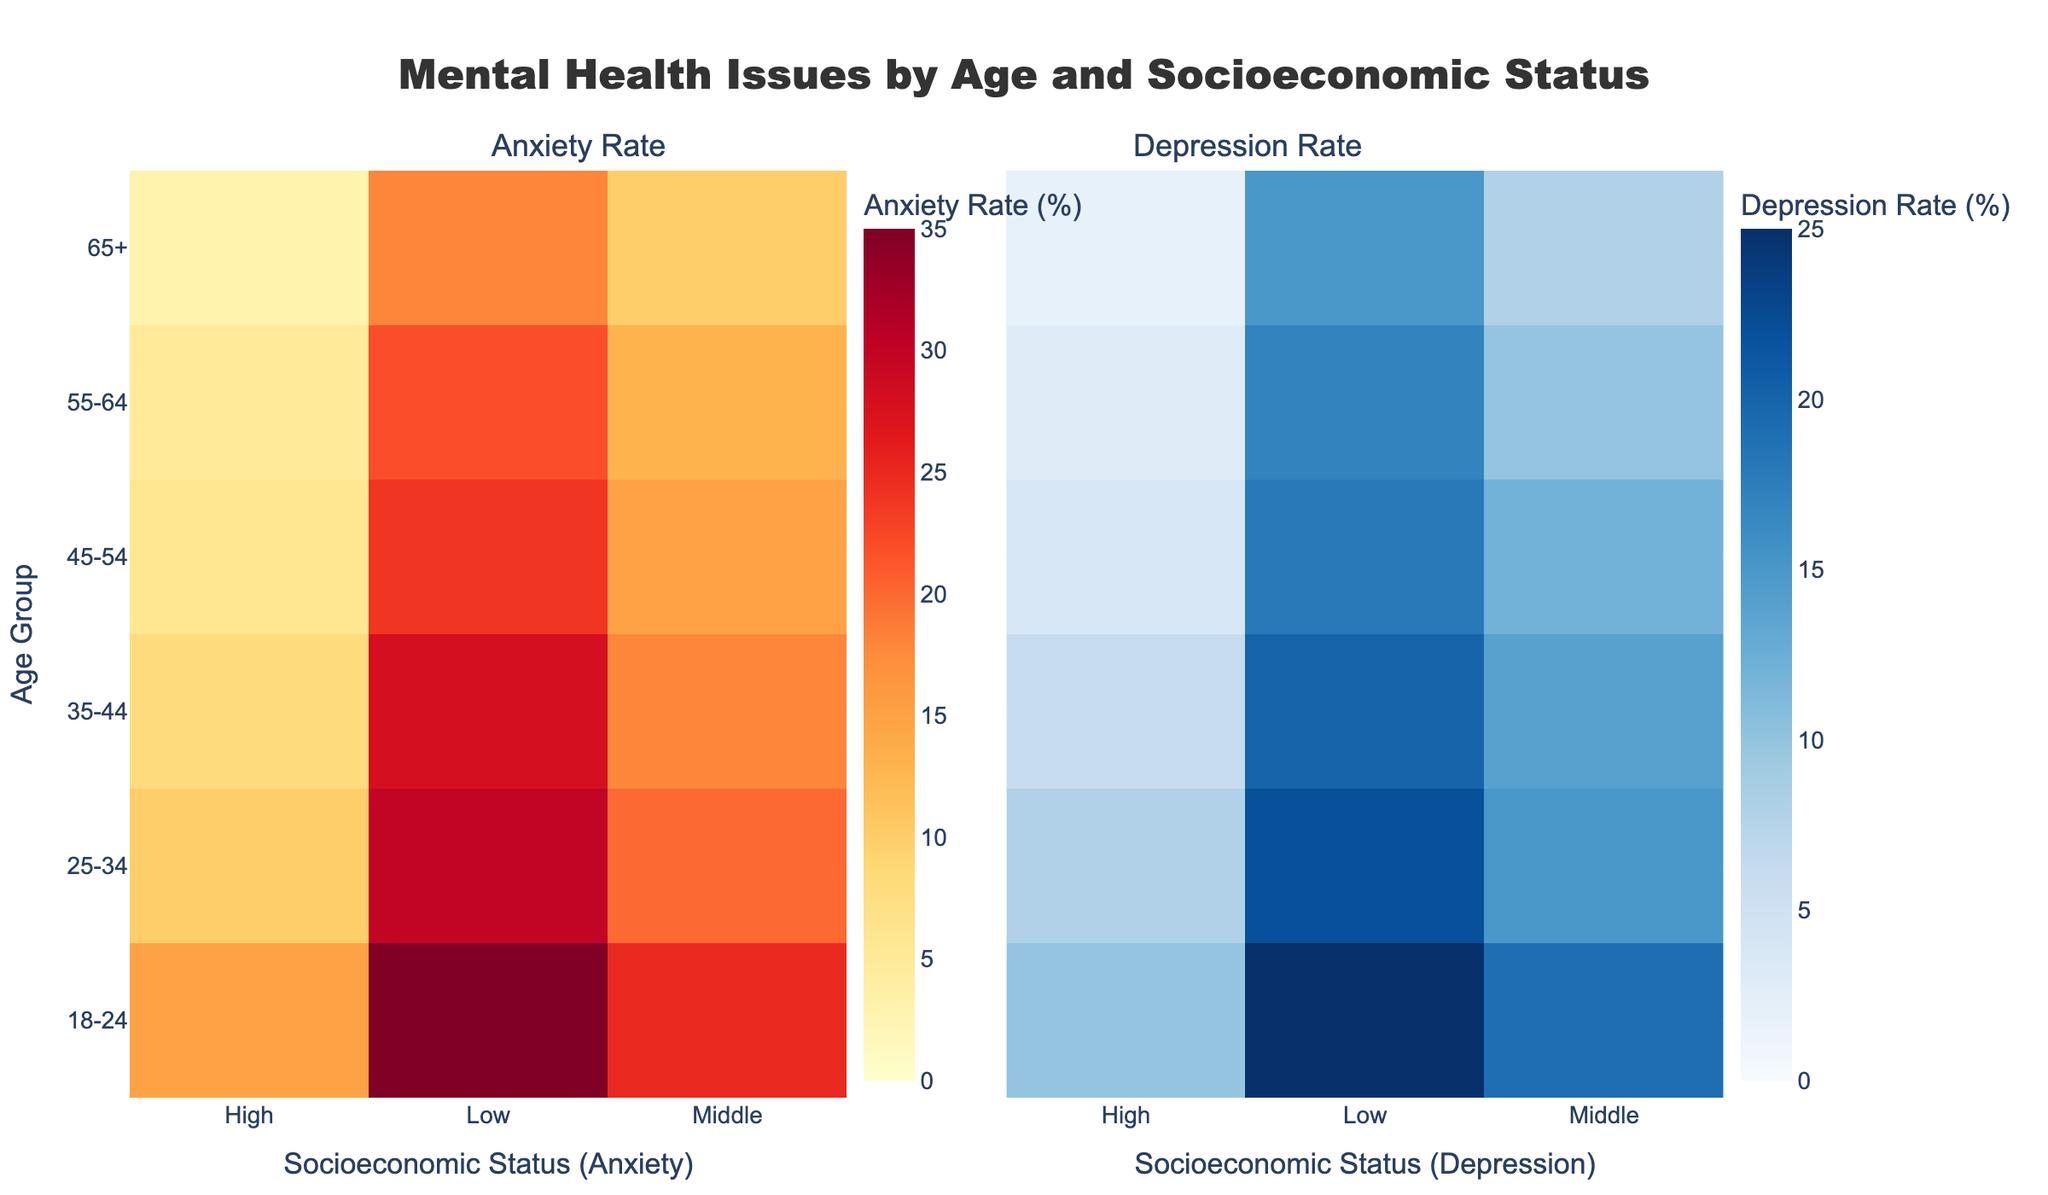What is the title of the figure? The title of the figure is usually displayed at the top. Based on the provided code, the title is located by identifying the 'title' parameter in the layout update section.
Answer: Mental Health Issues by Age and Socioeconomic Status What is the socioeconomic status with the highest anxiety rate for 18-24 age group? You can find this by looking at the heatmap cells corresponding to the 18-24 age group along the Anxiety Rate axis. The color intensity scale indicates the rate, where the highest intensity corresponds to the highest rate.
Answer: Low How does the anxiety rate change from the 18-24 to the 65+ age group for those in the Low socioeconomic status? Follow the Anxiety Rate heatmap vertically starting from 18-24 to 65+ along the Low socioeconomic status column. Note the rates and observe the trend.
Answer: It decreases What is the difference in the depression rate between the Low and High socioeconomic statuses for the 45-54 age group? Locate the 45-54 age group on the Depression Rate heatmap and compare the values in the Low and High socioeconomic status columns. Subtract the High status rate from the Low status rate.
Answer: 14% Which age group has the lowest rate of depression among all socioeconomic statuses? Scan through the entire Depression Rate heatmap to identify the age group with the cells indicating the lowest rates, regardless of the socioeconomic status.
Answer: 65+ Is there a pattern in the prevalence of anxiety rates across different socioeconomic statuses as age increases? Examine the Anxiety Rate heatmap horizontally for each socioeconomic status as age increases from 18-24 to 65+. Observe if the rates show a consistent increase, decrease, or remain stable.
Answer: General decrease Compare the depression rate trends with the anxiety rate trends for the High socioeconomic status. Check the trends in the respective heatmaps for the High socioeconomic status across all age groups. Compare if both rates increase, decrease, or follow a different pattern.
Answer: Both trends decrease What is the mean depression rate across all age groups for the Middle socioeconomic status? Locate the Middle socioeconomic status column in the Depression Rate heatmap, sum up the values for all age groups, and divide by the number of groups (6).
Answer: 12% For which socioeconomic status does the transition from 35-44 to 45-54 age group maintain the same anxiety rate? Identify the cells in the Anxiety Rate heatmap for the 35-44 and 45-54 age groups, and compare them for each socioeconomic status to find where the values remain identical.
Answer: None Which socioeconomic status has the least variation in depression rates across different age groups? To determine variation, assess the range (max value - min value) of depression rates for each socioeconomic status. The one with the smallest range has the least variation.
Answer: High 